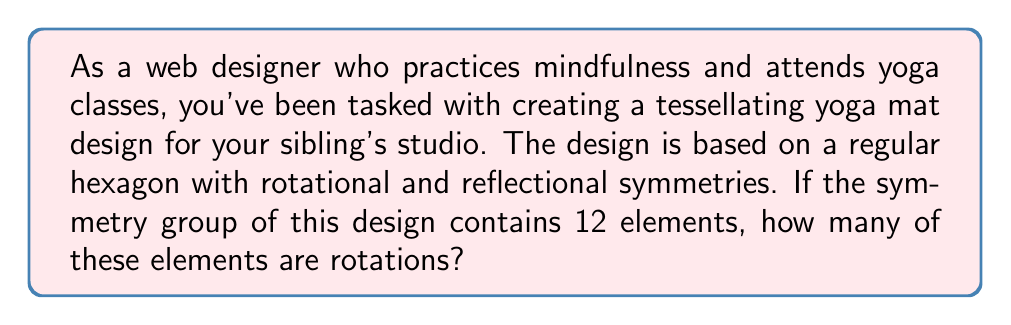Provide a solution to this math problem. Let's approach this step-by-step:

1) First, recall that the symmetry group of a regular hexagon is the dihedral group $D_6$, which has 12 elements in total.

2) The elements of $D_6$ can be divided into two types:
   a) Rotations
   b) Reflections

3) For a regular hexagon:
   - There are rotations of $0°, 60°, 120°, 180°, 240°, 300°$
   - There are 6 lines of reflection (3 through opposite vertices and 3 through the midpoints of opposite sides)

4) To count the number of rotations:
   - The rotation of $0°$ is the identity element
   - There are 5 non-trivial rotations ($60°, 120°, 180°, 240°, 300°$)
   - In total, there are 6 rotations

5) We can verify this by counting the reflections:
   - There are 6 reflections
   - $6 \text{ rotations} + 6 \text{ reflections} = 12 \text{ total elements}$

This aligns with the given information that the symmetry group has 12 elements.

The connection to mindfulness and yoga: Understanding the symmetry in the mat design can enhance focus during meditation and yoga practice, as it provides a balanced and harmonious visual reference point.
Answer: 6 elements of the symmetry group are rotations. 